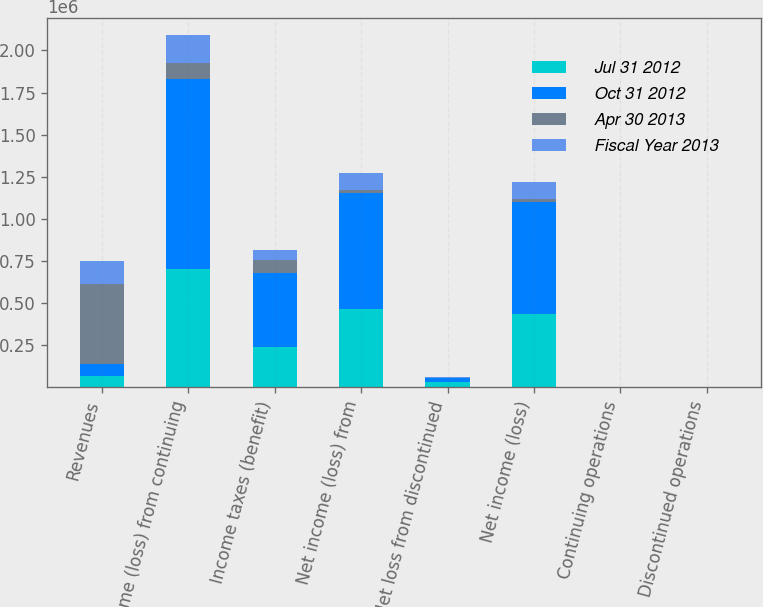<chart> <loc_0><loc_0><loc_500><loc_500><stacked_bar_chart><ecel><fcel>Revenues<fcel>Income (loss) from continuing<fcel>Income taxes (benefit)<fcel>Net income (loss) from<fcel>Net loss from discontinued<fcel>Net income (loss)<fcel>Continuing operations<fcel>Discontinued operations<nl><fcel>Jul 31 2012<fcel>70221<fcel>702011<fcel>236853<fcel>465158<fcel>31210<fcel>433948<fcel>1.7<fcel>0.11<nl><fcel>Oct 31 2012<fcel>70221<fcel>1.12984e+06<fcel>440914<fcel>688922<fcel>24582<fcel>664340<fcel>2.53<fcel>0.09<nl><fcel>Apr 30 2013<fcel>471979<fcel>96268<fcel>79353<fcel>16915<fcel>793<fcel>17708<fcel>0.06<fcel>0.01<nl><fcel>Fiscal Year 2013<fcel>137263<fcel>162288<fcel>61089<fcel>101199<fcel>4044<fcel>105243<fcel>0.37<fcel>0.02<nl></chart> 